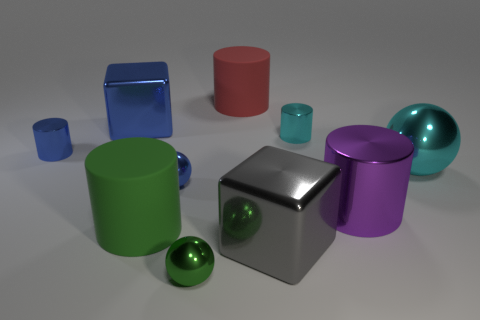What size is the shiny thing that is the same color as the big ball?
Your answer should be very brief. Small. What shape is the small thing that is the same color as the big ball?
Offer a very short reply. Cylinder. Does the block that is left of the big gray cube have the same material as the cyan object behind the small blue cylinder?
Offer a very short reply. Yes. How many shiny spheres are the same size as the red rubber cylinder?
Provide a short and direct response. 1. Is the number of big cyan metal balls less than the number of small shiny spheres?
Ensure brevity in your answer.  Yes. The small object in front of the big matte thing to the left of the green shiny object is what shape?
Your answer should be compact. Sphere. There is a blue object that is the same size as the cyan shiny ball; what is its shape?
Ensure brevity in your answer.  Cube. Are there any other objects of the same shape as the big purple thing?
Provide a succinct answer. Yes. What material is the red thing?
Offer a terse response. Rubber. Are there any tiny cyan metal cylinders behind the blue shiny block?
Your response must be concise. No. 